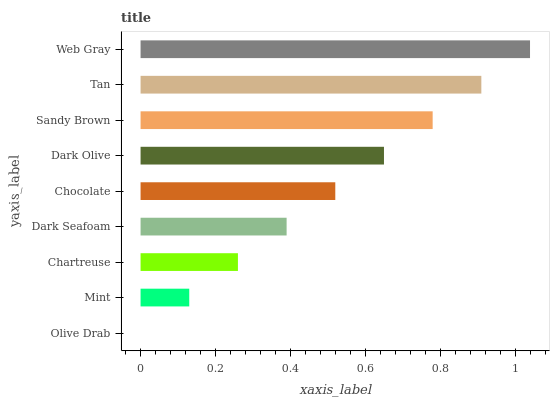Is Olive Drab the minimum?
Answer yes or no. Yes. Is Web Gray the maximum?
Answer yes or no. Yes. Is Mint the minimum?
Answer yes or no. No. Is Mint the maximum?
Answer yes or no. No. Is Mint greater than Olive Drab?
Answer yes or no. Yes. Is Olive Drab less than Mint?
Answer yes or no. Yes. Is Olive Drab greater than Mint?
Answer yes or no. No. Is Mint less than Olive Drab?
Answer yes or no. No. Is Chocolate the high median?
Answer yes or no. Yes. Is Chocolate the low median?
Answer yes or no. Yes. Is Chartreuse the high median?
Answer yes or no. No. Is Dark Seafoam the low median?
Answer yes or no. No. 